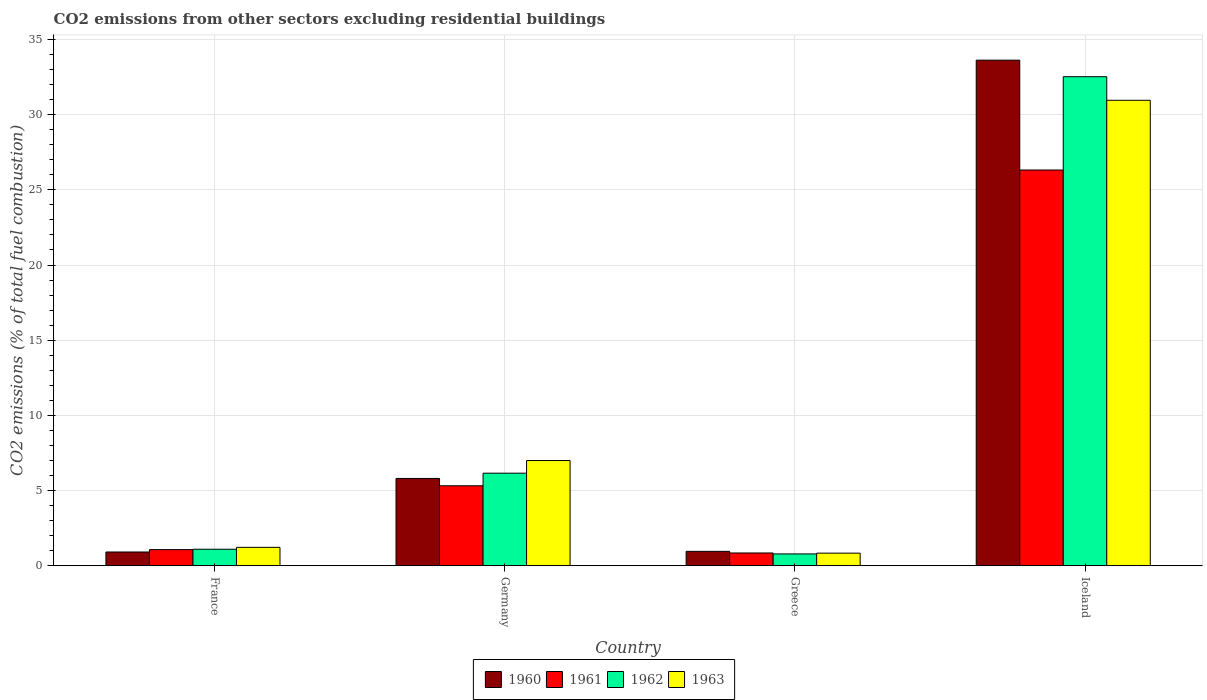How many bars are there on the 4th tick from the left?
Make the answer very short. 4. What is the label of the 1st group of bars from the left?
Keep it short and to the point. France. What is the total CO2 emitted in 1960 in Iceland?
Keep it short and to the point. 33.62. Across all countries, what is the maximum total CO2 emitted in 1960?
Offer a very short reply. 33.62. Across all countries, what is the minimum total CO2 emitted in 1961?
Provide a short and direct response. 0.85. What is the total total CO2 emitted in 1963 in the graph?
Offer a terse response. 40.02. What is the difference between the total CO2 emitted in 1961 in Germany and that in Iceland?
Your answer should be compact. -20.99. What is the difference between the total CO2 emitted in 1963 in Iceland and the total CO2 emitted in 1961 in France?
Offer a very short reply. 29.88. What is the average total CO2 emitted in 1960 per country?
Ensure brevity in your answer.  10.33. What is the difference between the total CO2 emitted of/in 1962 and total CO2 emitted of/in 1963 in Iceland?
Give a very brief answer. 1.57. What is the ratio of the total CO2 emitted in 1961 in France to that in Iceland?
Offer a very short reply. 0.04. Is the difference between the total CO2 emitted in 1962 in Germany and Iceland greater than the difference between the total CO2 emitted in 1963 in Germany and Iceland?
Your answer should be very brief. No. What is the difference between the highest and the second highest total CO2 emitted in 1960?
Ensure brevity in your answer.  -32.66. What is the difference between the highest and the lowest total CO2 emitted in 1960?
Make the answer very short. 32.7. In how many countries, is the total CO2 emitted in 1960 greater than the average total CO2 emitted in 1960 taken over all countries?
Provide a succinct answer. 1. Is the sum of the total CO2 emitted in 1960 in France and Germany greater than the maximum total CO2 emitted in 1962 across all countries?
Provide a short and direct response. No. What does the 3rd bar from the right in Germany represents?
Offer a terse response. 1961. Is it the case that in every country, the sum of the total CO2 emitted in 1961 and total CO2 emitted in 1962 is greater than the total CO2 emitted in 1963?
Your answer should be very brief. Yes. Are all the bars in the graph horizontal?
Offer a very short reply. No. Are the values on the major ticks of Y-axis written in scientific E-notation?
Keep it short and to the point. No. Where does the legend appear in the graph?
Keep it short and to the point. Bottom center. What is the title of the graph?
Your answer should be very brief. CO2 emissions from other sectors excluding residential buildings. Does "1976" appear as one of the legend labels in the graph?
Provide a succinct answer. No. What is the label or title of the X-axis?
Give a very brief answer. Country. What is the label or title of the Y-axis?
Ensure brevity in your answer.  CO2 emissions (% of total fuel combustion). What is the CO2 emissions (% of total fuel combustion) of 1960 in France?
Your response must be concise. 0.92. What is the CO2 emissions (% of total fuel combustion) in 1961 in France?
Your answer should be compact. 1.08. What is the CO2 emissions (% of total fuel combustion) in 1962 in France?
Provide a short and direct response. 1.1. What is the CO2 emissions (% of total fuel combustion) of 1963 in France?
Offer a very short reply. 1.23. What is the CO2 emissions (% of total fuel combustion) of 1960 in Germany?
Make the answer very short. 5.81. What is the CO2 emissions (% of total fuel combustion) of 1961 in Germany?
Provide a succinct answer. 5.32. What is the CO2 emissions (% of total fuel combustion) in 1962 in Germany?
Provide a short and direct response. 6.16. What is the CO2 emissions (% of total fuel combustion) of 1963 in Germany?
Your answer should be very brief. 7. What is the CO2 emissions (% of total fuel combustion) in 1960 in Greece?
Offer a terse response. 0.96. What is the CO2 emissions (% of total fuel combustion) of 1961 in Greece?
Keep it short and to the point. 0.85. What is the CO2 emissions (% of total fuel combustion) of 1962 in Greece?
Provide a short and direct response. 0.79. What is the CO2 emissions (% of total fuel combustion) in 1963 in Greece?
Offer a terse response. 0.84. What is the CO2 emissions (% of total fuel combustion) in 1960 in Iceland?
Offer a very short reply. 33.62. What is the CO2 emissions (% of total fuel combustion) of 1961 in Iceland?
Provide a succinct answer. 26.32. What is the CO2 emissions (% of total fuel combustion) in 1962 in Iceland?
Offer a very short reply. 32.52. What is the CO2 emissions (% of total fuel combustion) in 1963 in Iceland?
Give a very brief answer. 30.95. Across all countries, what is the maximum CO2 emissions (% of total fuel combustion) in 1960?
Offer a very short reply. 33.62. Across all countries, what is the maximum CO2 emissions (% of total fuel combustion) in 1961?
Provide a short and direct response. 26.32. Across all countries, what is the maximum CO2 emissions (% of total fuel combustion) in 1962?
Keep it short and to the point. 32.52. Across all countries, what is the maximum CO2 emissions (% of total fuel combustion) of 1963?
Keep it short and to the point. 30.95. Across all countries, what is the minimum CO2 emissions (% of total fuel combustion) of 1960?
Your response must be concise. 0.92. Across all countries, what is the minimum CO2 emissions (% of total fuel combustion) in 1961?
Offer a very short reply. 0.85. Across all countries, what is the minimum CO2 emissions (% of total fuel combustion) in 1962?
Make the answer very short. 0.79. Across all countries, what is the minimum CO2 emissions (% of total fuel combustion) in 1963?
Make the answer very short. 0.84. What is the total CO2 emissions (% of total fuel combustion) of 1960 in the graph?
Ensure brevity in your answer.  41.31. What is the total CO2 emissions (% of total fuel combustion) in 1961 in the graph?
Your answer should be compact. 33.57. What is the total CO2 emissions (% of total fuel combustion) of 1962 in the graph?
Provide a succinct answer. 40.57. What is the total CO2 emissions (% of total fuel combustion) in 1963 in the graph?
Provide a short and direct response. 40.02. What is the difference between the CO2 emissions (% of total fuel combustion) in 1960 in France and that in Germany?
Give a very brief answer. -4.89. What is the difference between the CO2 emissions (% of total fuel combustion) of 1961 in France and that in Germany?
Give a very brief answer. -4.25. What is the difference between the CO2 emissions (% of total fuel combustion) in 1962 in France and that in Germany?
Keep it short and to the point. -5.06. What is the difference between the CO2 emissions (% of total fuel combustion) in 1963 in France and that in Germany?
Keep it short and to the point. -5.77. What is the difference between the CO2 emissions (% of total fuel combustion) of 1960 in France and that in Greece?
Provide a succinct answer. -0.04. What is the difference between the CO2 emissions (% of total fuel combustion) in 1961 in France and that in Greece?
Your response must be concise. 0.22. What is the difference between the CO2 emissions (% of total fuel combustion) in 1962 in France and that in Greece?
Provide a succinct answer. 0.31. What is the difference between the CO2 emissions (% of total fuel combustion) in 1963 in France and that in Greece?
Keep it short and to the point. 0.39. What is the difference between the CO2 emissions (% of total fuel combustion) of 1960 in France and that in Iceland?
Keep it short and to the point. -32.7. What is the difference between the CO2 emissions (% of total fuel combustion) in 1961 in France and that in Iceland?
Offer a very short reply. -25.24. What is the difference between the CO2 emissions (% of total fuel combustion) in 1962 in France and that in Iceland?
Your answer should be compact. -31.42. What is the difference between the CO2 emissions (% of total fuel combustion) of 1963 in France and that in Iceland?
Provide a succinct answer. -29.73. What is the difference between the CO2 emissions (% of total fuel combustion) of 1960 in Germany and that in Greece?
Keep it short and to the point. 4.85. What is the difference between the CO2 emissions (% of total fuel combustion) of 1961 in Germany and that in Greece?
Your answer should be compact. 4.47. What is the difference between the CO2 emissions (% of total fuel combustion) of 1962 in Germany and that in Greece?
Ensure brevity in your answer.  5.37. What is the difference between the CO2 emissions (% of total fuel combustion) in 1963 in Germany and that in Greece?
Keep it short and to the point. 6.16. What is the difference between the CO2 emissions (% of total fuel combustion) of 1960 in Germany and that in Iceland?
Provide a succinct answer. -27.81. What is the difference between the CO2 emissions (% of total fuel combustion) of 1961 in Germany and that in Iceland?
Give a very brief answer. -20.99. What is the difference between the CO2 emissions (% of total fuel combustion) of 1962 in Germany and that in Iceland?
Give a very brief answer. -26.36. What is the difference between the CO2 emissions (% of total fuel combustion) of 1963 in Germany and that in Iceland?
Keep it short and to the point. -23.95. What is the difference between the CO2 emissions (% of total fuel combustion) of 1960 in Greece and that in Iceland?
Your answer should be very brief. -32.66. What is the difference between the CO2 emissions (% of total fuel combustion) in 1961 in Greece and that in Iceland?
Ensure brevity in your answer.  -25.46. What is the difference between the CO2 emissions (% of total fuel combustion) in 1962 in Greece and that in Iceland?
Ensure brevity in your answer.  -31.73. What is the difference between the CO2 emissions (% of total fuel combustion) of 1963 in Greece and that in Iceland?
Offer a very short reply. -30.11. What is the difference between the CO2 emissions (% of total fuel combustion) of 1960 in France and the CO2 emissions (% of total fuel combustion) of 1961 in Germany?
Make the answer very short. -4.4. What is the difference between the CO2 emissions (% of total fuel combustion) of 1960 in France and the CO2 emissions (% of total fuel combustion) of 1962 in Germany?
Make the answer very short. -5.24. What is the difference between the CO2 emissions (% of total fuel combustion) in 1960 in France and the CO2 emissions (% of total fuel combustion) in 1963 in Germany?
Keep it short and to the point. -6.08. What is the difference between the CO2 emissions (% of total fuel combustion) of 1961 in France and the CO2 emissions (% of total fuel combustion) of 1962 in Germany?
Provide a succinct answer. -5.08. What is the difference between the CO2 emissions (% of total fuel combustion) in 1961 in France and the CO2 emissions (% of total fuel combustion) in 1963 in Germany?
Ensure brevity in your answer.  -5.92. What is the difference between the CO2 emissions (% of total fuel combustion) of 1962 in France and the CO2 emissions (% of total fuel combustion) of 1963 in Germany?
Keep it short and to the point. -5.9. What is the difference between the CO2 emissions (% of total fuel combustion) in 1960 in France and the CO2 emissions (% of total fuel combustion) in 1961 in Greece?
Your response must be concise. 0.06. What is the difference between the CO2 emissions (% of total fuel combustion) of 1960 in France and the CO2 emissions (% of total fuel combustion) of 1962 in Greece?
Offer a terse response. 0.13. What is the difference between the CO2 emissions (% of total fuel combustion) of 1960 in France and the CO2 emissions (% of total fuel combustion) of 1963 in Greece?
Keep it short and to the point. 0.08. What is the difference between the CO2 emissions (% of total fuel combustion) in 1961 in France and the CO2 emissions (% of total fuel combustion) in 1962 in Greece?
Your response must be concise. 0.29. What is the difference between the CO2 emissions (% of total fuel combustion) in 1961 in France and the CO2 emissions (% of total fuel combustion) in 1963 in Greece?
Keep it short and to the point. 0.23. What is the difference between the CO2 emissions (% of total fuel combustion) in 1962 in France and the CO2 emissions (% of total fuel combustion) in 1963 in Greece?
Keep it short and to the point. 0.26. What is the difference between the CO2 emissions (% of total fuel combustion) of 1960 in France and the CO2 emissions (% of total fuel combustion) of 1961 in Iceland?
Keep it short and to the point. -25.4. What is the difference between the CO2 emissions (% of total fuel combustion) of 1960 in France and the CO2 emissions (% of total fuel combustion) of 1962 in Iceland?
Ensure brevity in your answer.  -31.6. What is the difference between the CO2 emissions (% of total fuel combustion) in 1960 in France and the CO2 emissions (% of total fuel combustion) in 1963 in Iceland?
Your answer should be very brief. -30.04. What is the difference between the CO2 emissions (% of total fuel combustion) in 1961 in France and the CO2 emissions (% of total fuel combustion) in 1962 in Iceland?
Offer a very short reply. -31.44. What is the difference between the CO2 emissions (% of total fuel combustion) in 1961 in France and the CO2 emissions (% of total fuel combustion) in 1963 in Iceland?
Ensure brevity in your answer.  -29.88. What is the difference between the CO2 emissions (% of total fuel combustion) of 1962 in France and the CO2 emissions (% of total fuel combustion) of 1963 in Iceland?
Offer a terse response. -29.85. What is the difference between the CO2 emissions (% of total fuel combustion) in 1960 in Germany and the CO2 emissions (% of total fuel combustion) in 1961 in Greece?
Provide a succinct answer. 4.96. What is the difference between the CO2 emissions (% of total fuel combustion) of 1960 in Germany and the CO2 emissions (% of total fuel combustion) of 1962 in Greece?
Offer a terse response. 5.02. What is the difference between the CO2 emissions (% of total fuel combustion) in 1960 in Germany and the CO2 emissions (% of total fuel combustion) in 1963 in Greece?
Make the answer very short. 4.97. What is the difference between the CO2 emissions (% of total fuel combustion) of 1961 in Germany and the CO2 emissions (% of total fuel combustion) of 1962 in Greece?
Your response must be concise. 4.53. What is the difference between the CO2 emissions (% of total fuel combustion) of 1961 in Germany and the CO2 emissions (% of total fuel combustion) of 1963 in Greece?
Provide a succinct answer. 4.48. What is the difference between the CO2 emissions (% of total fuel combustion) in 1962 in Germany and the CO2 emissions (% of total fuel combustion) in 1963 in Greece?
Your answer should be very brief. 5.32. What is the difference between the CO2 emissions (% of total fuel combustion) in 1960 in Germany and the CO2 emissions (% of total fuel combustion) in 1961 in Iceland?
Offer a very short reply. -20.51. What is the difference between the CO2 emissions (% of total fuel combustion) in 1960 in Germany and the CO2 emissions (% of total fuel combustion) in 1962 in Iceland?
Your answer should be compact. -26.71. What is the difference between the CO2 emissions (% of total fuel combustion) in 1960 in Germany and the CO2 emissions (% of total fuel combustion) in 1963 in Iceland?
Offer a terse response. -25.14. What is the difference between the CO2 emissions (% of total fuel combustion) of 1961 in Germany and the CO2 emissions (% of total fuel combustion) of 1962 in Iceland?
Give a very brief answer. -27.2. What is the difference between the CO2 emissions (% of total fuel combustion) of 1961 in Germany and the CO2 emissions (% of total fuel combustion) of 1963 in Iceland?
Offer a very short reply. -25.63. What is the difference between the CO2 emissions (% of total fuel combustion) in 1962 in Germany and the CO2 emissions (% of total fuel combustion) in 1963 in Iceland?
Your answer should be compact. -24.79. What is the difference between the CO2 emissions (% of total fuel combustion) of 1960 in Greece and the CO2 emissions (% of total fuel combustion) of 1961 in Iceland?
Make the answer very short. -25.36. What is the difference between the CO2 emissions (% of total fuel combustion) in 1960 in Greece and the CO2 emissions (% of total fuel combustion) in 1962 in Iceland?
Make the answer very short. -31.56. What is the difference between the CO2 emissions (% of total fuel combustion) in 1960 in Greece and the CO2 emissions (% of total fuel combustion) in 1963 in Iceland?
Make the answer very short. -29.99. What is the difference between the CO2 emissions (% of total fuel combustion) in 1961 in Greece and the CO2 emissions (% of total fuel combustion) in 1962 in Iceland?
Make the answer very short. -31.67. What is the difference between the CO2 emissions (% of total fuel combustion) of 1961 in Greece and the CO2 emissions (% of total fuel combustion) of 1963 in Iceland?
Ensure brevity in your answer.  -30.1. What is the difference between the CO2 emissions (% of total fuel combustion) of 1962 in Greece and the CO2 emissions (% of total fuel combustion) of 1963 in Iceland?
Your answer should be compact. -30.16. What is the average CO2 emissions (% of total fuel combustion) of 1960 per country?
Your response must be concise. 10.33. What is the average CO2 emissions (% of total fuel combustion) of 1961 per country?
Give a very brief answer. 8.39. What is the average CO2 emissions (% of total fuel combustion) of 1962 per country?
Your response must be concise. 10.14. What is the average CO2 emissions (% of total fuel combustion) of 1963 per country?
Your answer should be compact. 10. What is the difference between the CO2 emissions (% of total fuel combustion) in 1960 and CO2 emissions (% of total fuel combustion) in 1961 in France?
Your response must be concise. -0.16. What is the difference between the CO2 emissions (% of total fuel combustion) of 1960 and CO2 emissions (% of total fuel combustion) of 1962 in France?
Your response must be concise. -0.18. What is the difference between the CO2 emissions (% of total fuel combustion) in 1960 and CO2 emissions (% of total fuel combustion) in 1963 in France?
Your answer should be compact. -0.31. What is the difference between the CO2 emissions (% of total fuel combustion) of 1961 and CO2 emissions (% of total fuel combustion) of 1962 in France?
Your answer should be compact. -0.02. What is the difference between the CO2 emissions (% of total fuel combustion) of 1961 and CO2 emissions (% of total fuel combustion) of 1963 in France?
Offer a terse response. -0.15. What is the difference between the CO2 emissions (% of total fuel combustion) in 1962 and CO2 emissions (% of total fuel combustion) in 1963 in France?
Your answer should be very brief. -0.13. What is the difference between the CO2 emissions (% of total fuel combustion) of 1960 and CO2 emissions (% of total fuel combustion) of 1961 in Germany?
Make the answer very short. 0.49. What is the difference between the CO2 emissions (% of total fuel combustion) of 1960 and CO2 emissions (% of total fuel combustion) of 1962 in Germany?
Give a very brief answer. -0.35. What is the difference between the CO2 emissions (% of total fuel combustion) of 1960 and CO2 emissions (% of total fuel combustion) of 1963 in Germany?
Your answer should be very brief. -1.19. What is the difference between the CO2 emissions (% of total fuel combustion) of 1961 and CO2 emissions (% of total fuel combustion) of 1962 in Germany?
Keep it short and to the point. -0.84. What is the difference between the CO2 emissions (% of total fuel combustion) in 1961 and CO2 emissions (% of total fuel combustion) in 1963 in Germany?
Ensure brevity in your answer.  -1.68. What is the difference between the CO2 emissions (% of total fuel combustion) in 1962 and CO2 emissions (% of total fuel combustion) in 1963 in Germany?
Offer a terse response. -0.84. What is the difference between the CO2 emissions (% of total fuel combustion) of 1960 and CO2 emissions (% of total fuel combustion) of 1961 in Greece?
Your answer should be compact. 0.11. What is the difference between the CO2 emissions (% of total fuel combustion) of 1960 and CO2 emissions (% of total fuel combustion) of 1962 in Greece?
Provide a short and direct response. 0.17. What is the difference between the CO2 emissions (% of total fuel combustion) of 1960 and CO2 emissions (% of total fuel combustion) of 1963 in Greece?
Offer a terse response. 0.12. What is the difference between the CO2 emissions (% of total fuel combustion) in 1961 and CO2 emissions (% of total fuel combustion) in 1962 in Greece?
Your answer should be compact. 0.06. What is the difference between the CO2 emissions (% of total fuel combustion) of 1961 and CO2 emissions (% of total fuel combustion) of 1963 in Greece?
Keep it short and to the point. 0.01. What is the difference between the CO2 emissions (% of total fuel combustion) in 1962 and CO2 emissions (% of total fuel combustion) in 1963 in Greece?
Keep it short and to the point. -0.05. What is the difference between the CO2 emissions (% of total fuel combustion) of 1960 and CO2 emissions (% of total fuel combustion) of 1961 in Iceland?
Your response must be concise. 7.3. What is the difference between the CO2 emissions (% of total fuel combustion) of 1960 and CO2 emissions (% of total fuel combustion) of 1962 in Iceland?
Give a very brief answer. 1.1. What is the difference between the CO2 emissions (% of total fuel combustion) in 1960 and CO2 emissions (% of total fuel combustion) in 1963 in Iceland?
Your answer should be very brief. 2.67. What is the difference between the CO2 emissions (% of total fuel combustion) of 1961 and CO2 emissions (% of total fuel combustion) of 1962 in Iceland?
Keep it short and to the point. -6.2. What is the difference between the CO2 emissions (% of total fuel combustion) of 1961 and CO2 emissions (% of total fuel combustion) of 1963 in Iceland?
Provide a succinct answer. -4.64. What is the difference between the CO2 emissions (% of total fuel combustion) of 1962 and CO2 emissions (% of total fuel combustion) of 1963 in Iceland?
Your response must be concise. 1.57. What is the ratio of the CO2 emissions (% of total fuel combustion) in 1960 in France to that in Germany?
Your response must be concise. 0.16. What is the ratio of the CO2 emissions (% of total fuel combustion) in 1961 in France to that in Germany?
Ensure brevity in your answer.  0.2. What is the ratio of the CO2 emissions (% of total fuel combustion) in 1962 in France to that in Germany?
Your response must be concise. 0.18. What is the ratio of the CO2 emissions (% of total fuel combustion) in 1963 in France to that in Germany?
Provide a succinct answer. 0.18. What is the ratio of the CO2 emissions (% of total fuel combustion) in 1960 in France to that in Greece?
Make the answer very short. 0.96. What is the ratio of the CO2 emissions (% of total fuel combustion) of 1961 in France to that in Greece?
Provide a succinct answer. 1.26. What is the ratio of the CO2 emissions (% of total fuel combustion) in 1962 in France to that in Greece?
Offer a terse response. 1.39. What is the ratio of the CO2 emissions (% of total fuel combustion) in 1963 in France to that in Greece?
Keep it short and to the point. 1.46. What is the ratio of the CO2 emissions (% of total fuel combustion) in 1960 in France to that in Iceland?
Give a very brief answer. 0.03. What is the ratio of the CO2 emissions (% of total fuel combustion) of 1961 in France to that in Iceland?
Your answer should be compact. 0.04. What is the ratio of the CO2 emissions (% of total fuel combustion) in 1962 in France to that in Iceland?
Give a very brief answer. 0.03. What is the ratio of the CO2 emissions (% of total fuel combustion) of 1963 in France to that in Iceland?
Keep it short and to the point. 0.04. What is the ratio of the CO2 emissions (% of total fuel combustion) in 1960 in Germany to that in Greece?
Provide a succinct answer. 6.05. What is the ratio of the CO2 emissions (% of total fuel combustion) of 1961 in Germany to that in Greece?
Offer a very short reply. 6.24. What is the ratio of the CO2 emissions (% of total fuel combustion) of 1962 in Germany to that in Greece?
Keep it short and to the point. 7.8. What is the ratio of the CO2 emissions (% of total fuel combustion) of 1963 in Germany to that in Greece?
Ensure brevity in your answer.  8.32. What is the ratio of the CO2 emissions (% of total fuel combustion) in 1960 in Germany to that in Iceland?
Make the answer very short. 0.17. What is the ratio of the CO2 emissions (% of total fuel combustion) of 1961 in Germany to that in Iceland?
Provide a succinct answer. 0.2. What is the ratio of the CO2 emissions (% of total fuel combustion) of 1962 in Germany to that in Iceland?
Your answer should be compact. 0.19. What is the ratio of the CO2 emissions (% of total fuel combustion) in 1963 in Germany to that in Iceland?
Offer a terse response. 0.23. What is the ratio of the CO2 emissions (% of total fuel combustion) in 1960 in Greece to that in Iceland?
Offer a terse response. 0.03. What is the ratio of the CO2 emissions (% of total fuel combustion) in 1961 in Greece to that in Iceland?
Offer a very short reply. 0.03. What is the ratio of the CO2 emissions (% of total fuel combustion) in 1962 in Greece to that in Iceland?
Your answer should be compact. 0.02. What is the ratio of the CO2 emissions (% of total fuel combustion) in 1963 in Greece to that in Iceland?
Keep it short and to the point. 0.03. What is the difference between the highest and the second highest CO2 emissions (% of total fuel combustion) in 1960?
Offer a very short reply. 27.81. What is the difference between the highest and the second highest CO2 emissions (% of total fuel combustion) of 1961?
Give a very brief answer. 20.99. What is the difference between the highest and the second highest CO2 emissions (% of total fuel combustion) in 1962?
Your answer should be very brief. 26.36. What is the difference between the highest and the second highest CO2 emissions (% of total fuel combustion) of 1963?
Your answer should be very brief. 23.95. What is the difference between the highest and the lowest CO2 emissions (% of total fuel combustion) of 1960?
Ensure brevity in your answer.  32.7. What is the difference between the highest and the lowest CO2 emissions (% of total fuel combustion) in 1961?
Provide a succinct answer. 25.46. What is the difference between the highest and the lowest CO2 emissions (% of total fuel combustion) of 1962?
Your response must be concise. 31.73. What is the difference between the highest and the lowest CO2 emissions (% of total fuel combustion) in 1963?
Ensure brevity in your answer.  30.11. 